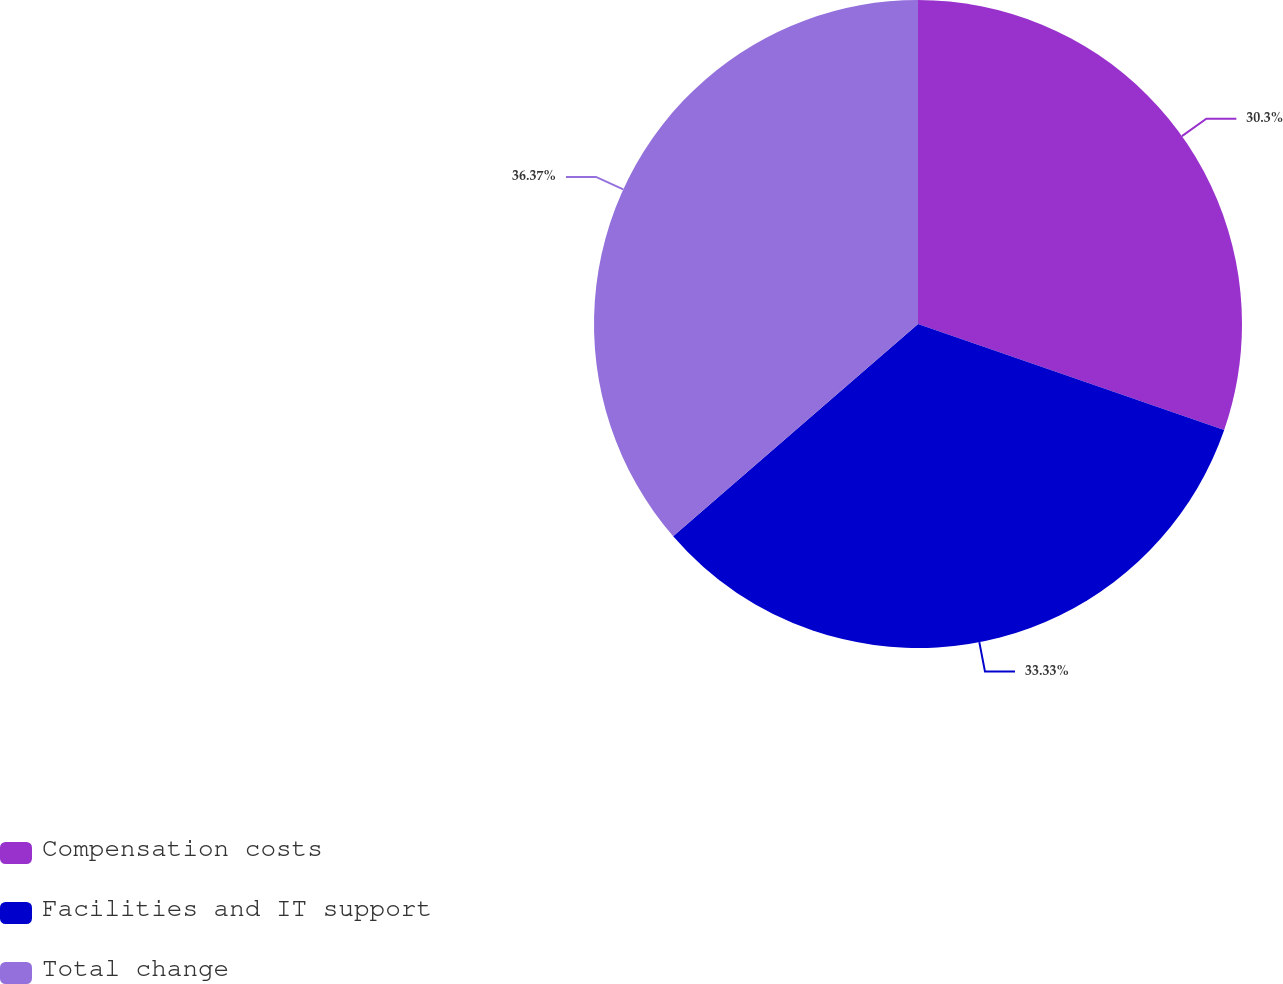Convert chart. <chart><loc_0><loc_0><loc_500><loc_500><pie_chart><fcel>Compensation costs<fcel>Facilities and IT support<fcel>Total change<nl><fcel>30.3%<fcel>33.33%<fcel>36.36%<nl></chart> 